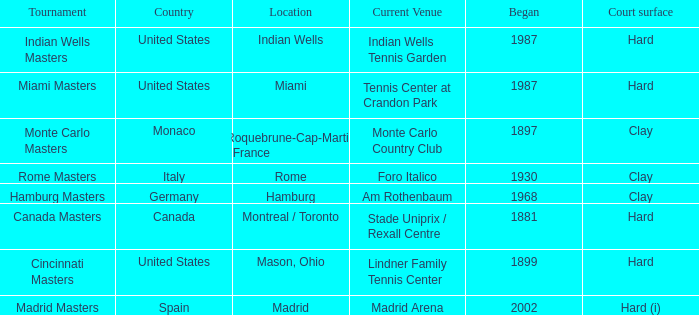Give me the full table as a dictionary. {'header': ['Tournament', 'Country', 'Location', 'Current Venue', 'Began', 'Court surface'], 'rows': [['Indian Wells Masters', 'United States', 'Indian Wells', 'Indian Wells Tennis Garden', '1987', 'Hard'], ['Miami Masters', 'United States', 'Miami', 'Tennis Center at Crandon Park', '1987', 'Hard'], ['Monte Carlo Masters', 'Monaco', 'Roquebrune-Cap-Martin , France', 'Monte Carlo Country Club', '1897', 'Clay'], ['Rome Masters', 'Italy', 'Rome', 'Foro Italico', '1930', 'Clay'], ['Hamburg Masters', 'Germany', 'Hamburg', 'Am Rothenbaum', '1968', 'Clay'], ['Canada Masters', 'Canada', 'Montreal / Toronto', 'Stade Uniprix / Rexall Centre', '1881', 'Hard'], ['Cincinnati Masters', 'United States', 'Mason, Ohio', 'Lindner Family Tennis Center', '1899', 'Hard'], ['Madrid Masters', 'Spain', 'Madrid', 'Madrid Arena', '2002', 'Hard (i)']]} What is the current venue for the Miami Masters tournament? Tennis Center at Crandon Park. 